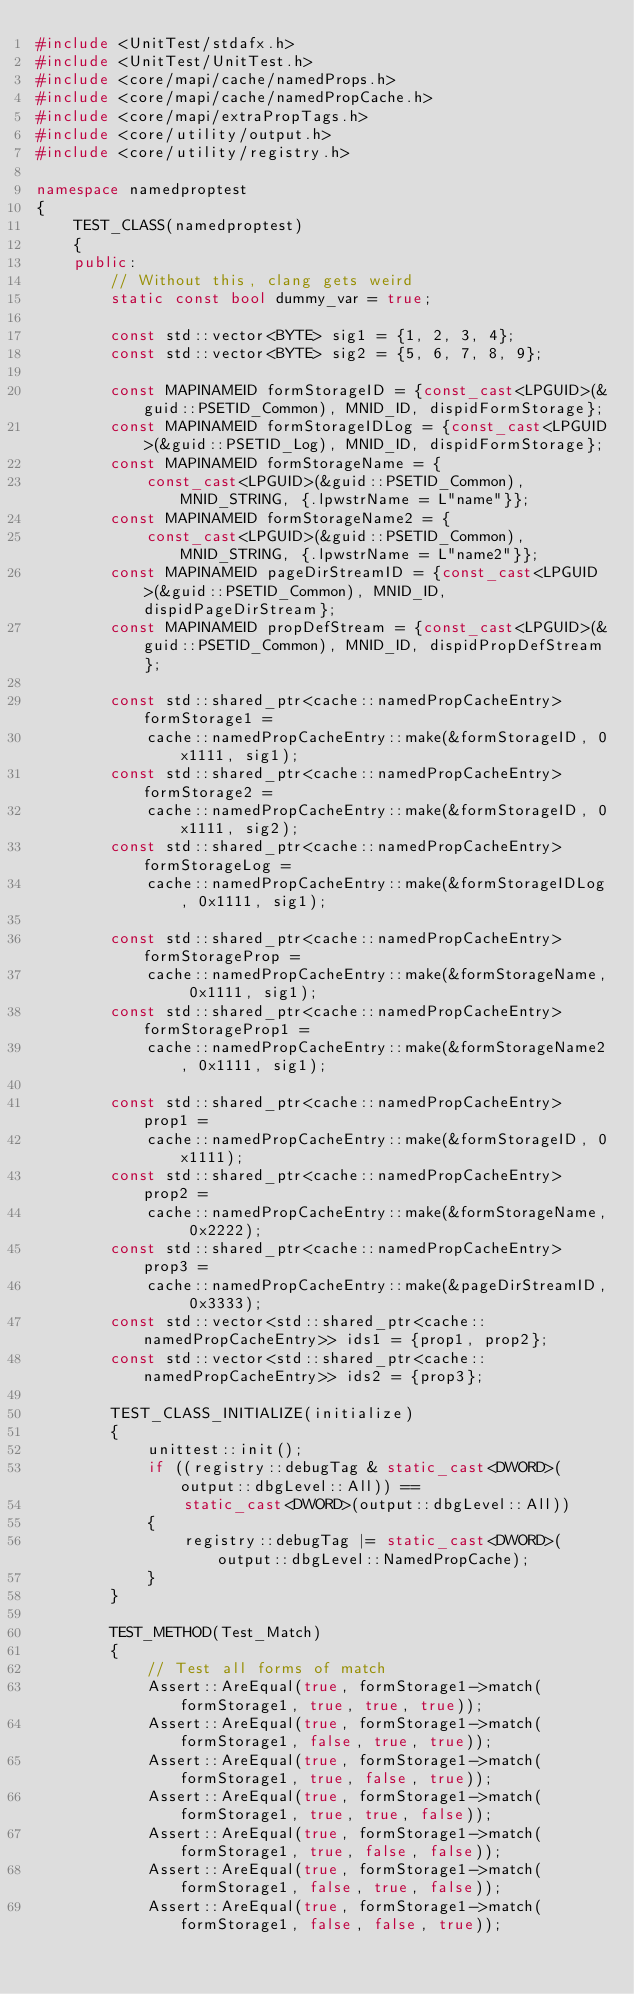<code> <loc_0><loc_0><loc_500><loc_500><_C++_>#include <UnitTest/stdafx.h>
#include <UnitTest/UnitTest.h>
#include <core/mapi/cache/namedProps.h>
#include <core/mapi/cache/namedPropCache.h>
#include <core/mapi/extraPropTags.h>
#include <core/utility/output.h>
#include <core/utility/registry.h>

namespace namedproptest
{
	TEST_CLASS(namedproptest)
	{
	public:
		// Without this, clang gets weird
		static const bool dummy_var = true;

		const std::vector<BYTE> sig1 = {1, 2, 3, 4};
		const std::vector<BYTE> sig2 = {5, 6, 7, 8, 9};

		const MAPINAMEID formStorageID = {const_cast<LPGUID>(&guid::PSETID_Common), MNID_ID, dispidFormStorage};
		const MAPINAMEID formStorageIDLog = {const_cast<LPGUID>(&guid::PSETID_Log), MNID_ID, dispidFormStorage};
		const MAPINAMEID formStorageName = {
			const_cast<LPGUID>(&guid::PSETID_Common), MNID_STRING, {.lpwstrName = L"name"}};
		const MAPINAMEID formStorageName2 = {
			const_cast<LPGUID>(&guid::PSETID_Common), MNID_STRING, {.lpwstrName = L"name2"}};
		const MAPINAMEID pageDirStreamID = {const_cast<LPGUID>(&guid::PSETID_Common), MNID_ID, dispidPageDirStream};
		const MAPINAMEID propDefStream = {const_cast<LPGUID>(&guid::PSETID_Common), MNID_ID, dispidPropDefStream};

		const std::shared_ptr<cache::namedPropCacheEntry> formStorage1 =
			cache::namedPropCacheEntry::make(&formStorageID, 0x1111, sig1);
		const std::shared_ptr<cache::namedPropCacheEntry> formStorage2 =
			cache::namedPropCacheEntry::make(&formStorageID, 0x1111, sig2);
		const std::shared_ptr<cache::namedPropCacheEntry> formStorageLog =
			cache::namedPropCacheEntry::make(&formStorageIDLog, 0x1111, sig1);

		const std::shared_ptr<cache::namedPropCacheEntry> formStorageProp =
			cache::namedPropCacheEntry::make(&formStorageName, 0x1111, sig1);
		const std::shared_ptr<cache::namedPropCacheEntry> formStorageProp1 =
			cache::namedPropCacheEntry::make(&formStorageName2, 0x1111, sig1);

		const std::shared_ptr<cache::namedPropCacheEntry> prop1 =
			cache::namedPropCacheEntry::make(&formStorageID, 0x1111);
		const std::shared_ptr<cache::namedPropCacheEntry> prop2 =
			cache::namedPropCacheEntry::make(&formStorageName, 0x2222);
		const std::shared_ptr<cache::namedPropCacheEntry> prop3 =
			cache::namedPropCacheEntry::make(&pageDirStreamID, 0x3333);
		const std::vector<std::shared_ptr<cache::namedPropCacheEntry>> ids1 = {prop1, prop2};
		const std::vector<std::shared_ptr<cache::namedPropCacheEntry>> ids2 = {prop3};

		TEST_CLASS_INITIALIZE(initialize)
		{
			unittest::init();
			if ((registry::debugTag & static_cast<DWORD>(output::dbgLevel::All)) ==
				static_cast<DWORD>(output::dbgLevel::All))
			{
				registry::debugTag |= static_cast<DWORD>(output::dbgLevel::NamedPropCache);
			}
		}

		TEST_METHOD(Test_Match)
		{
			// Test all forms of match
			Assert::AreEqual(true, formStorage1->match(formStorage1, true, true, true));
			Assert::AreEqual(true, formStorage1->match(formStorage1, false, true, true));
			Assert::AreEqual(true, formStorage1->match(formStorage1, true, false, true));
			Assert::AreEqual(true, formStorage1->match(formStorage1, true, true, false));
			Assert::AreEqual(true, formStorage1->match(formStorage1, true, false, false));
			Assert::AreEqual(true, formStorage1->match(formStorage1, false, true, false));
			Assert::AreEqual(true, formStorage1->match(formStorage1, false, false, true));</code> 